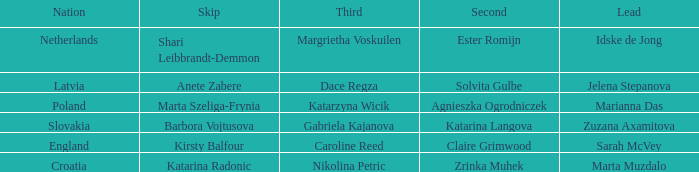What is the name of the second who has Caroline Reed as third? Claire Grimwood. 